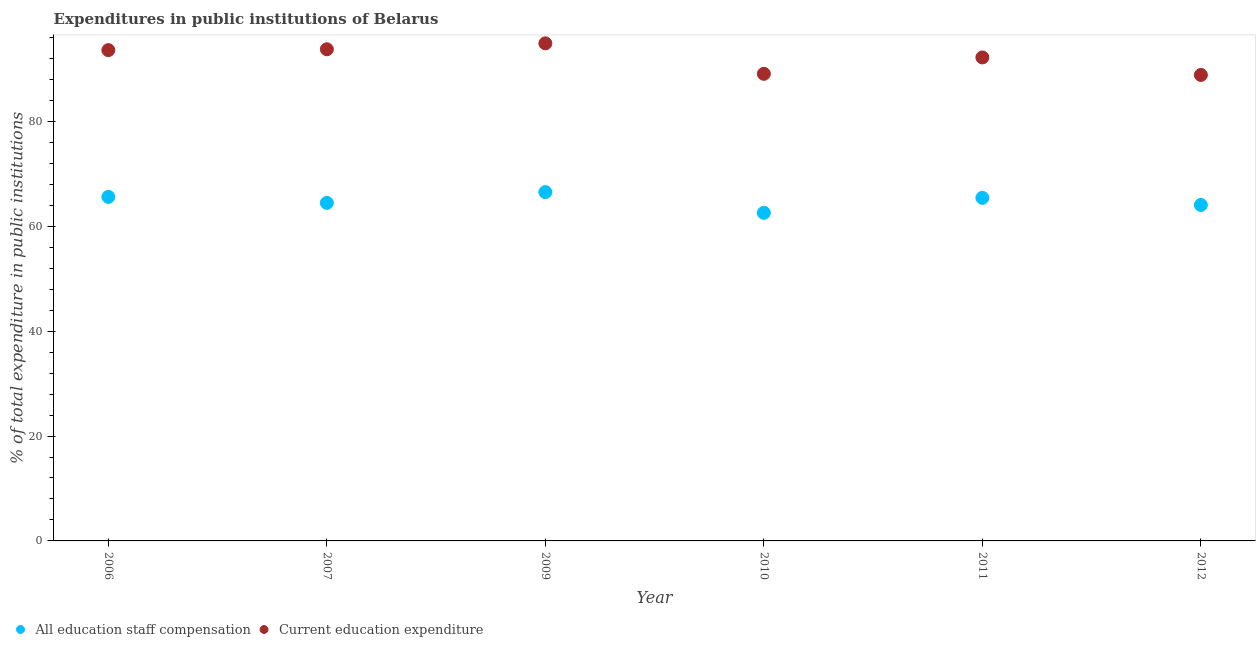Is the number of dotlines equal to the number of legend labels?
Your answer should be very brief. Yes. What is the expenditure in staff compensation in 2011?
Keep it short and to the point. 65.42. Across all years, what is the maximum expenditure in staff compensation?
Make the answer very short. 66.51. Across all years, what is the minimum expenditure in staff compensation?
Your answer should be compact. 62.57. In which year was the expenditure in staff compensation maximum?
Offer a terse response. 2009. In which year was the expenditure in education minimum?
Offer a very short reply. 2012. What is the total expenditure in staff compensation in the graph?
Provide a short and direct response. 388.63. What is the difference between the expenditure in education in 2009 and that in 2010?
Your answer should be compact. 5.81. What is the difference between the expenditure in education in 2007 and the expenditure in staff compensation in 2006?
Provide a short and direct response. 28.14. What is the average expenditure in staff compensation per year?
Your response must be concise. 64.77. In the year 2006, what is the difference between the expenditure in education and expenditure in staff compensation?
Give a very brief answer. 27.98. In how many years, is the expenditure in staff compensation greater than 52 %?
Ensure brevity in your answer.  6. What is the ratio of the expenditure in staff compensation in 2011 to that in 2012?
Provide a short and direct response. 1.02. Is the expenditure in staff compensation in 2006 less than that in 2009?
Offer a terse response. Yes. Is the difference between the expenditure in staff compensation in 2006 and 2009 greater than the difference between the expenditure in education in 2006 and 2009?
Offer a terse response. Yes. What is the difference between the highest and the second highest expenditure in education?
Provide a short and direct response. 1.13. What is the difference between the highest and the lowest expenditure in staff compensation?
Offer a very short reply. 3.94. In how many years, is the expenditure in staff compensation greater than the average expenditure in staff compensation taken over all years?
Your response must be concise. 3. How many dotlines are there?
Keep it short and to the point. 2. How many years are there in the graph?
Ensure brevity in your answer.  6. What is the difference between two consecutive major ticks on the Y-axis?
Provide a short and direct response. 20. Are the values on the major ticks of Y-axis written in scientific E-notation?
Make the answer very short. No. Does the graph contain any zero values?
Your response must be concise. No. How many legend labels are there?
Provide a short and direct response. 2. How are the legend labels stacked?
Your answer should be very brief. Horizontal. What is the title of the graph?
Provide a succinct answer. Expenditures in public institutions of Belarus. Does "Female entrants" appear as one of the legend labels in the graph?
Make the answer very short. No. What is the label or title of the Y-axis?
Ensure brevity in your answer.  % of total expenditure in public institutions. What is the % of total expenditure in public institutions of All education staff compensation in 2006?
Your answer should be very brief. 65.6. What is the % of total expenditure in public institutions in Current education expenditure in 2006?
Your answer should be very brief. 93.59. What is the % of total expenditure in public institutions of All education staff compensation in 2007?
Your answer should be compact. 64.46. What is the % of total expenditure in public institutions of Current education expenditure in 2007?
Provide a short and direct response. 93.75. What is the % of total expenditure in public institutions in All education staff compensation in 2009?
Your answer should be compact. 66.51. What is the % of total expenditure in public institutions in Current education expenditure in 2009?
Ensure brevity in your answer.  94.88. What is the % of total expenditure in public institutions in All education staff compensation in 2010?
Offer a very short reply. 62.57. What is the % of total expenditure in public institutions in Current education expenditure in 2010?
Give a very brief answer. 89.07. What is the % of total expenditure in public institutions in All education staff compensation in 2011?
Your answer should be compact. 65.42. What is the % of total expenditure in public institutions in Current education expenditure in 2011?
Your answer should be very brief. 92.2. What is the % of total expenditure in public institutions of All education staff compensation in 2012?
Give a very brief answer. 64.06. What is the % of total expenditure in public institutions in Current education expenditure in 2012?
Provide a succinct answer. 88.86. Across all years, what is the maximum % of total expenditure in public institutions in All education staff compensation?
Provide a succinct answer. 66.51. Across all years, what is the maximum % of total expenditure in public institutions in Current education expenditure?
Give a very brief answer. 94.88. Across all years, what is the minimum % of total expenditure in public institutions in All education staff compensation?
Offer a terse response. 62.57. Across all years, what is the minimum % of total expenditure in public institutions in Current education expenditure?
Offer a very short reply. 88.86. What is the total % of total expenditure in public institutions of All education staff compensation in the graph?
Keep it short and to the point. 388.63. What is the total % of total expenditure in public institutions of Current education expenditure in the graph?
Make the answer very short. 552.34. What is the difference between the % of total expenditure in public institutions in All education staff compensation in 2006 and that in 2007?
Give a very brief answer. 1.14. What is the difference between the % of total expenditure in public institutions in Current education expenditure in 2006 and that in 2007?
Provide a succinct answer. -0.16. What is the difference between the % of total expenditure in public institutions of All education staff compensation in 2006 and that in 2009?
Make the answer very short. -0.91. What is the difference between the % of total expenditure in public institutions of Current education expenditure in 2006 and that in 2009?
Your response must be concise. -1.29. What is the difference between the % of total expenditure in public institutions of All education staff compensation in 2006 and that in 2010?
Make the answer very short. 3.04. What is the difference between the % of total expenditure in public institutions of Current education expenditure in 2006 and that in 2010?
Offer a very short reply. 4.52. What is the difference between the % of total expenditure in public institutions of All education staff compensation in 2006 and that in 2011?
Offer a very short reply. 0.19. What is the difference between the % of total expenditure in public institutions of Current education expenditure in 2006 and that in 2011?
Give a very brief answer. 1.39. What is the difference between the % of total expenditure in public institutions in All education staff compensation in 2006 and that in 2012?
Ensure brevity in your answer.  1.54. What is the difference between the % of total expenditure in public institutions of Current education expenditure in 2006 and that in 2012?
Offer a terse response. 4.73. What is the difference between the % of total expenditure in public institutions in All education staff compensation in 2007 and that in 2009?
Make the answer very short. -2.05. What is the difference between the % of total expenditure in public institutions in Current education expenditure in 2007 and that in 2009?
Ensure brevity in your answer.  -1.13. What is the difference between the % of total expenditure in public institutions in All education staff compensation in 2007 and that in 2010?
Your response must be concise. 1.89. What is the difference between the % of total expenditure in public institutions of Current education expenditure in 2007 and that in 2010?
Ensure brevity in your answer.  4.68. What is the difference between the % of total expenditure in public institutions in All education staff compensation in 2007 and that in 2011?
Ensure brevity in your answer.  -0.96. What is the difference between the % of total expenditure in public institutions in Current education expenditure in 2007 and that in 2011?
Your response must be concise. 1.55. What is the difference between the % of total expenditure in public institutions in All education staff compensation in 2007 and that in 2012?
Your answer should be very brief. 0.4. What is the difference between the % of total expenditure in public institutions of Current education expenditure in 2007 and that in 2012?
Ensure brevity in your answer.  4.89. What is the difference between the % of total expenditure in public institutions of All education staff compensation in 2009 and that in 2010?
Your answer should be compact. 3.94. What is the difference between the % of total expenditure in public institutions of Current education expenditure in 2009 and that in 2010?
Offer a terse response. 5.81. What is the difference between the % of total expenditure in public institutions in All education staff compensation in 2009 and that in 2011?
Make the answer very short. 1.09. What is the difference between the % of total expenditure in public institutions in Current education expenditure in 2009 and that in 2011?
Give a very brief answer. 2.68. What is the difference between the % of total expenditure in public institutions of All education staff compensation in 2009 and that in 2012?
Your response must be concise. 2.45. What is the difference between the % of total expenditure in public institutions in Current education expenditure in 2009 and that in 2012?
Your answer should be very brief. 6.03. What is the difference between the % of total expenditure in public institutions in All education staff compensation in 2010 and that in 2011?
Give a very brief answer. -2.85. What is the difference between the % of total expenditure in public institutions in Current education expenditure in 2010 and that in 2011?
Keep it short and to the point. -3.12. What is the difference between the % of total expenditure in public institutions in All education staff compensation in 2010 and that in 2012?
Offer a terse response. -1.49. What is the difference between the % of total expenditure in public institutions in Current education expenditure in 2010 and that in 2012?
Ensure brevity in your answer.  0.22. What is the difference between the % of total expenditure in public institutions in All education staff compensation in 2011 and that in 2012?
Offer a terse response. 1.36. What is the difference between the % of total expenditure in public institutions of Current education expenditure in 2011 and that in 2012?
Make the answer very short. 3.34. What is the difference between the % of total expenditure in public institutions in All education staff compensation in 2006 and the % of total expenditure in public institutions in Current education expenditure in 2007?
Offer a terse response. -28.14. What is the difference between the % of total expenditure in public institutions in All education staff compensation in 2006 and the % of total expenditure in public institutions in Current education expenditure in 2009?
Offer a very short reply. -29.28. What is the difference between the % of total expenditure in public institutions of All education staff compensation in 2006 and the % of total expenditure in public institutions of Current education expenditure in 2010?
Make the answer very short. -23.47. What is the difference between the % of total expenditure in public institutions of All education staff compensation in 2006 and the % of total expenditure in public institutions of Current education expenditure in 2011?
Your response must be concise. -26.59. What is the difference between the % of total expenditure in public institutions in All education staff compensation in 2006 and the % of total expenditure in public institutions in Current education expenditure in 2012?
Make the answer very short. -23.25. What is the difference between the % of total expenditure in public institutions of All education staff compensation in 2007 and the % of total expenditure in public institutions of Current education expenditure in 2009?
Offer a very short reply. -30.42. What is the difference between the % of total expenditure in public institutions of All education staff compensation in 2007 and the % of total expenditure in public institutions of Current education expenditure in 2010?
Keep it short and to the point. -24.61. What is the difference between the % of total expenditure in public institutions of All education staff compensation in 2007 and the % of total expenditure in public institutions of Current education expenditure in 2011?
Make the answer very short. -27.73. What is the difference between the % of total expenditure in public institutions of All education staff compensation in 2007 and the % of total expenditure in public institutions of Current education expenditure in 2012?
Provide a short and direct response. -24.39. What is the difference between the % of total expenditure in public institutions in All education staff compensation in 2009 and the % of total expenditure in public institutions in Current education expenditure in 2010?
Provide a short and direct response. -22.56. What is the difference between the % of total expenditure in public institutions of All education staff compensation in 2009 and the % of total expenditure in public institutions of Current education expenditure in 2011?
Keep it short and to the point. -25.68. What is the difference between the % of total expenditure in public institutions of All education staff compensation in 2009 and the % of total expenditure in public institutions of Current education expenditure in 2012?
Give a very brief answer. -22.34. What is the difference between the % of total expenditure in public institutions of All education staff compensation in 2010 and the % of total expenditure in public institutions of Current education expenditure in 2011?
Give a very brief answer. -29.63. What is the difference between the % of total expenditure in public institutions of All education staff compensation in 2010 and the % of total expenditure in public institutions of Current education expenditure in 2012?
Keep it short and to the point. -26.29. What is the difference between the % of total expenditure in public institutions of All education staff compensation in 2011 and the % of total expenditure in public institutions of Current education expenditure in 2012?
Offer a terse response. -23.44. What is the average % of total expenditure in public institutions of All education staff compensation per year?
Keep it short and to the point. 64.77. What is the average % of total expenditure in public institutions of Current education expenditure per year?
Provide a succinct answer. 92.06. In the year 2006, what is the difference between the % of total expenditure in public institutions in All education staff compensation and % of total expenditure in public institutions in Current education expenditure?
Give a very brief answer. -27.98. In the year 2007, what is the difference between the % of total expenditure in public institutions of All education staff compensation and % of total expenditure in public institutions of Current education expenditure?
Offer a terse response. -29.29. In the year 2009, what is the difference between the % of total expenditure in public institutions in All education staff compensation and % of total expenditure in public institutions in Current education expenditure?
Ensure brevity in your answer.  -28.37. In the year 2010, what is the difference between the % of total expenditure in public institutions in All education staff compensation and % of total expenditure in public institutions in Current education expenditure?
Provide a short and direct response. -26.5. In the year 2011, what is the difference between the % of total expenditure in public institutions of All education staff compensation and % of total expenditure in public institutions of Current education expenditure?
Make the answer very short. -26.78. In the year 2012, what is the difference between the % of total expenditure in public institutions in All education staff compensation and % of total expenditure in public institutions in Current education expenditure?
Ensure brevity in your answer.  -24.79. What is the ratio of the % of total expenditure in public institutions of All education staff compensation in 2006 to that in 2007?
Make the answer very short. 1.02. What is the ratio of the % of total expenditure in public institutions in All education staff compensation in 2006 to that in 2009?
Make the answer very short. 0.99. What is the ratio of the % of total expenditure in public institutions of Current education expenditure in 2006 to that in 2009?
Your response must be concise. 0.99. What is the ratio of the % of total expenditure in public institutions in All education staff compensation in 2006 to that in 2010?
Keep it short and to the point. 1.05. What is the ratio of the % of total expenditure in public institutions in Current education expenditure in 2006 to that in 2010?
Keep it short and to the point. 1.05. What is the ratio of the % of total expenditure in public institutions in Current education expenditure in 2006 to that in 2011?
Provide a short and direct response. 1.02. What is the ratio of the % of total expenditure in public institutions of All education staff compensation in 2006 to that in 2012?
Give a very brief answer. 1.02. What is the ratio of the % of total expenditure in public institutions in Current education expenditure in 2006 to that in 2012?
Provide a short and direct response. 1.05. What is the ratio of the % of total expenditure in public institutions of All education staff compensation in 2007 to that in 2009?
Give a very brief answer. 0.97. What is the ratio of the % of total expenditure in public institutions of All education staff compensation in 2007 to that in 2010?
Your answer should be very brief. 1.03. What is the ratio of the % of total expenditure in public institutions of Current education expenditure in 2007 to that in 2010?
Ensure brevity in your answer.  1.05. What is the ratio of the % of total expenditure in public institutions of All education staff compensation in 2007 to that in 2011?
Offer a terse response. 0.99. What is the ratio of the % of total expenditure in public institutions in Current education expenditure in 2007 to that in 2011?
Keep it short and to the point. 1.02. What is the ratio of the % of total expenditure in public institutions in Current education expenditure in 2007 to that in 2012?
Make the answer very short. 1.06. What is the ratio of the % of total expenditure in public institutions in All education staff compensation in 2009 to that in 2010?
Offer a terse response. 1.06. What is the ratio of the % of total expenditure in public institutions in Current education expenditure in 2009 to that in 2010?
Offer a terse response. 1.07. What is the ratio of the % of total expenditure in public institutions in All education staff compensation in 2009 to that in 2011?
Keep it short and to the point. 1.02. What is the ratio of the % of total expenditure in public institutions of Current education expenditure in 2009 to that in 2011?
Keep it short and to the point. 1.03. What is the ratio of the % of total expenditure in public institutions in All education staff compensation in 2009 to that in 2012?
Ensure brevity in your answer.  1.04. What is the ratio of the % of total expenditure in public institutions of Current education expenditure in 2009 to that in 2012?
Your response must be concise. 1.07. What is the ratio of the % of total expenditure in public institutions in All education staff compensation in 2010 to that in 2011?
Your response must be concise. 0.96. What is the ratio of the % of total expenditure in public institutions of Current education expenditure in 2010 to that in 2011?
Provide a short and direct response. 0.97. What is the ratio of the % of total expenditure in public institutions of All education staff compensation in 2010 to that in 2012?
Your answer should be compact. 0.98. What is the ratio of the % of total expenditure in public institutions in Current education expenditure in 2010 to that in 2012?
Your response must be concise. 1. What is the ratio of the % of total expenditure in public institutions of All education staff compensation in 2011 to that in 2012?
Give a very brief answer. 1.02. What is the ratio of the % of total expenditure in public institutions of Current education expenditure in 2011 to that in 2012?
Ensure brevity in your answer.  1.04. What is the difference between the highest and the second highest % of total expenditure in public institutions in All education staff compensation?
Offer a terse response. 0.91. What is the difference between the highest and the second highest % of total expenditure in public institutions in Current education expenditure?
Offer a terse response. 1.13. What is the difference between the highest and the lowest % of total expenditure in public institutions of All education staff compensation?
Keep it short and to the point. 3.94. What is the difference between the highest and the lowest % of total expenditure in public institutions in Current education expenditure?
Ensure brevity in your answer.  6.03. 